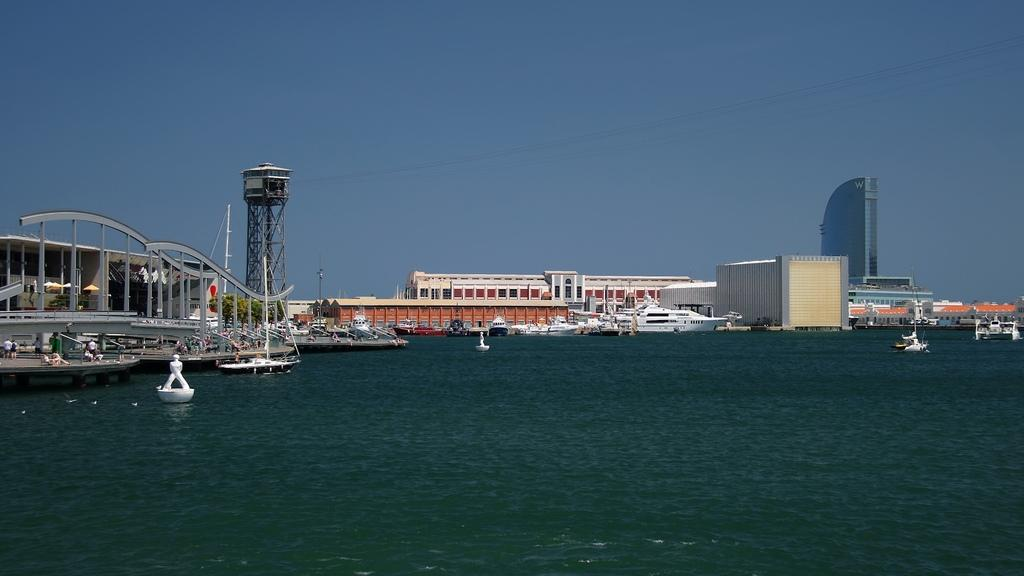What is at the bottom of the image? There is water at the bottom of the image. What is located in the middle of the image? There is a white ship in the middle of the image. What type of structures can be seen in the image? There are buildings in the image. What is happening on the right side of the image? There are boats moving on the water on the right side of the image. What is visible at the top of the image? The sky is visible at the top of the image. What type of cracker is floating on the water in the image? There is no cracker present in the image; it features water, a white ship, buildings, boats, and the sky. What is the weight of the thing that is not visible in the image? It is impossible to determine the weight of something that is not present in the image. 